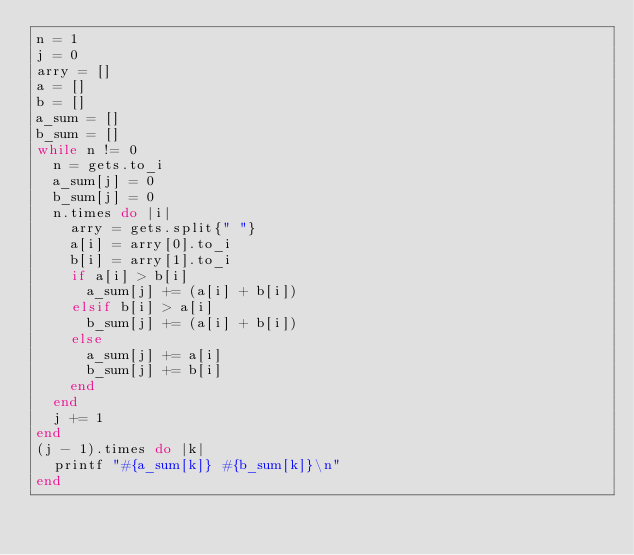Convert code to text. <code><loc_0><loc_0><loc_500><loc_500><_Ruby_>n = 1
j = 0
arry = []
a = []
b = []
a_sum = []
b_sum = []
while n != 0
	n = gets.to_i
	a_sum[j] = 0
	b_sum[j] = 0
	n.times do |i|
		arry = gets.split{" "}
		a[i] = arry[0].to_i
		b[i] = arry[1].to_i
		if a[i] > b[i]
			a_sum[j] += (a[i] + b[i])
		elsif b[i] > a[i]
			b_sum[j] += (a[i] + b[i])
		else
			a_sum[j] += a[i]
			b_sum[j] += b[i]
		end
	end
	j += 1
end
(j - 1).times do |k|
	printf "#{a_sum[k]} #{b_sum[k]}\n"
end</code> 